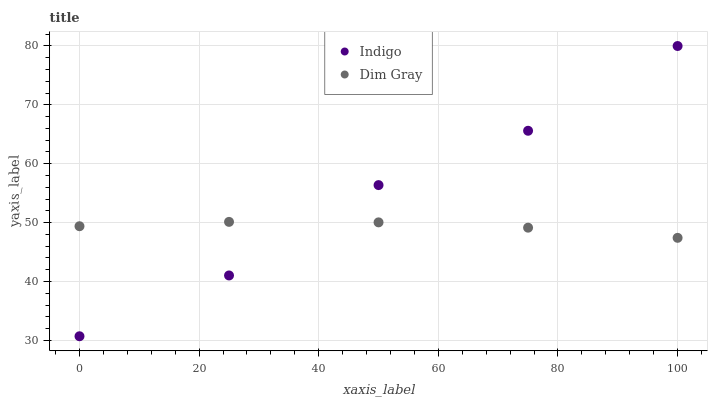Does Dim Gray have the minimum area under the curve?
Answer yes or no. Yes. Does Indigo have the maximum area under the curve?
Answer yes or no. Yes. Does Indigo have the minimum area under the curve?
Answer yes or no. No. Is Dim Gray the smoothest?
Answer yes or no. Yes. Is Indigo the roughest?
Answer yes or no. Yes. Is Indigo the smoothest?
Answer yes or no. No. Does Indigo have the lowest value?
Answer yes or no. Yes. Does Indigo have the highest value?
Answer yes or no. Yes. Does Dim Gray intersect Indigo?
Answer yes or no. Yes. Is Dim Gray less than Indigo?
Answer yes or no. No. Is Dim Gray greater than Indigo?
Answer yes or no. No. 